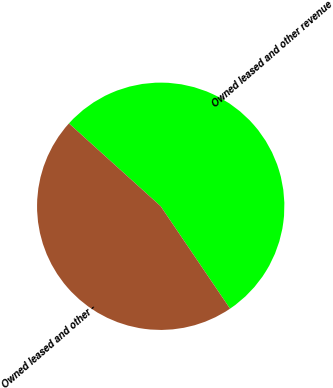Convert chart to OTSL. <chart><loc_0><loc_0><loc_500><loc_500><pie_chart><fcel>Owned leased and other revenue<fcel>Owned leased and other -<nl><fcel>53.84%<fcel>46.16%<nl></chart> 